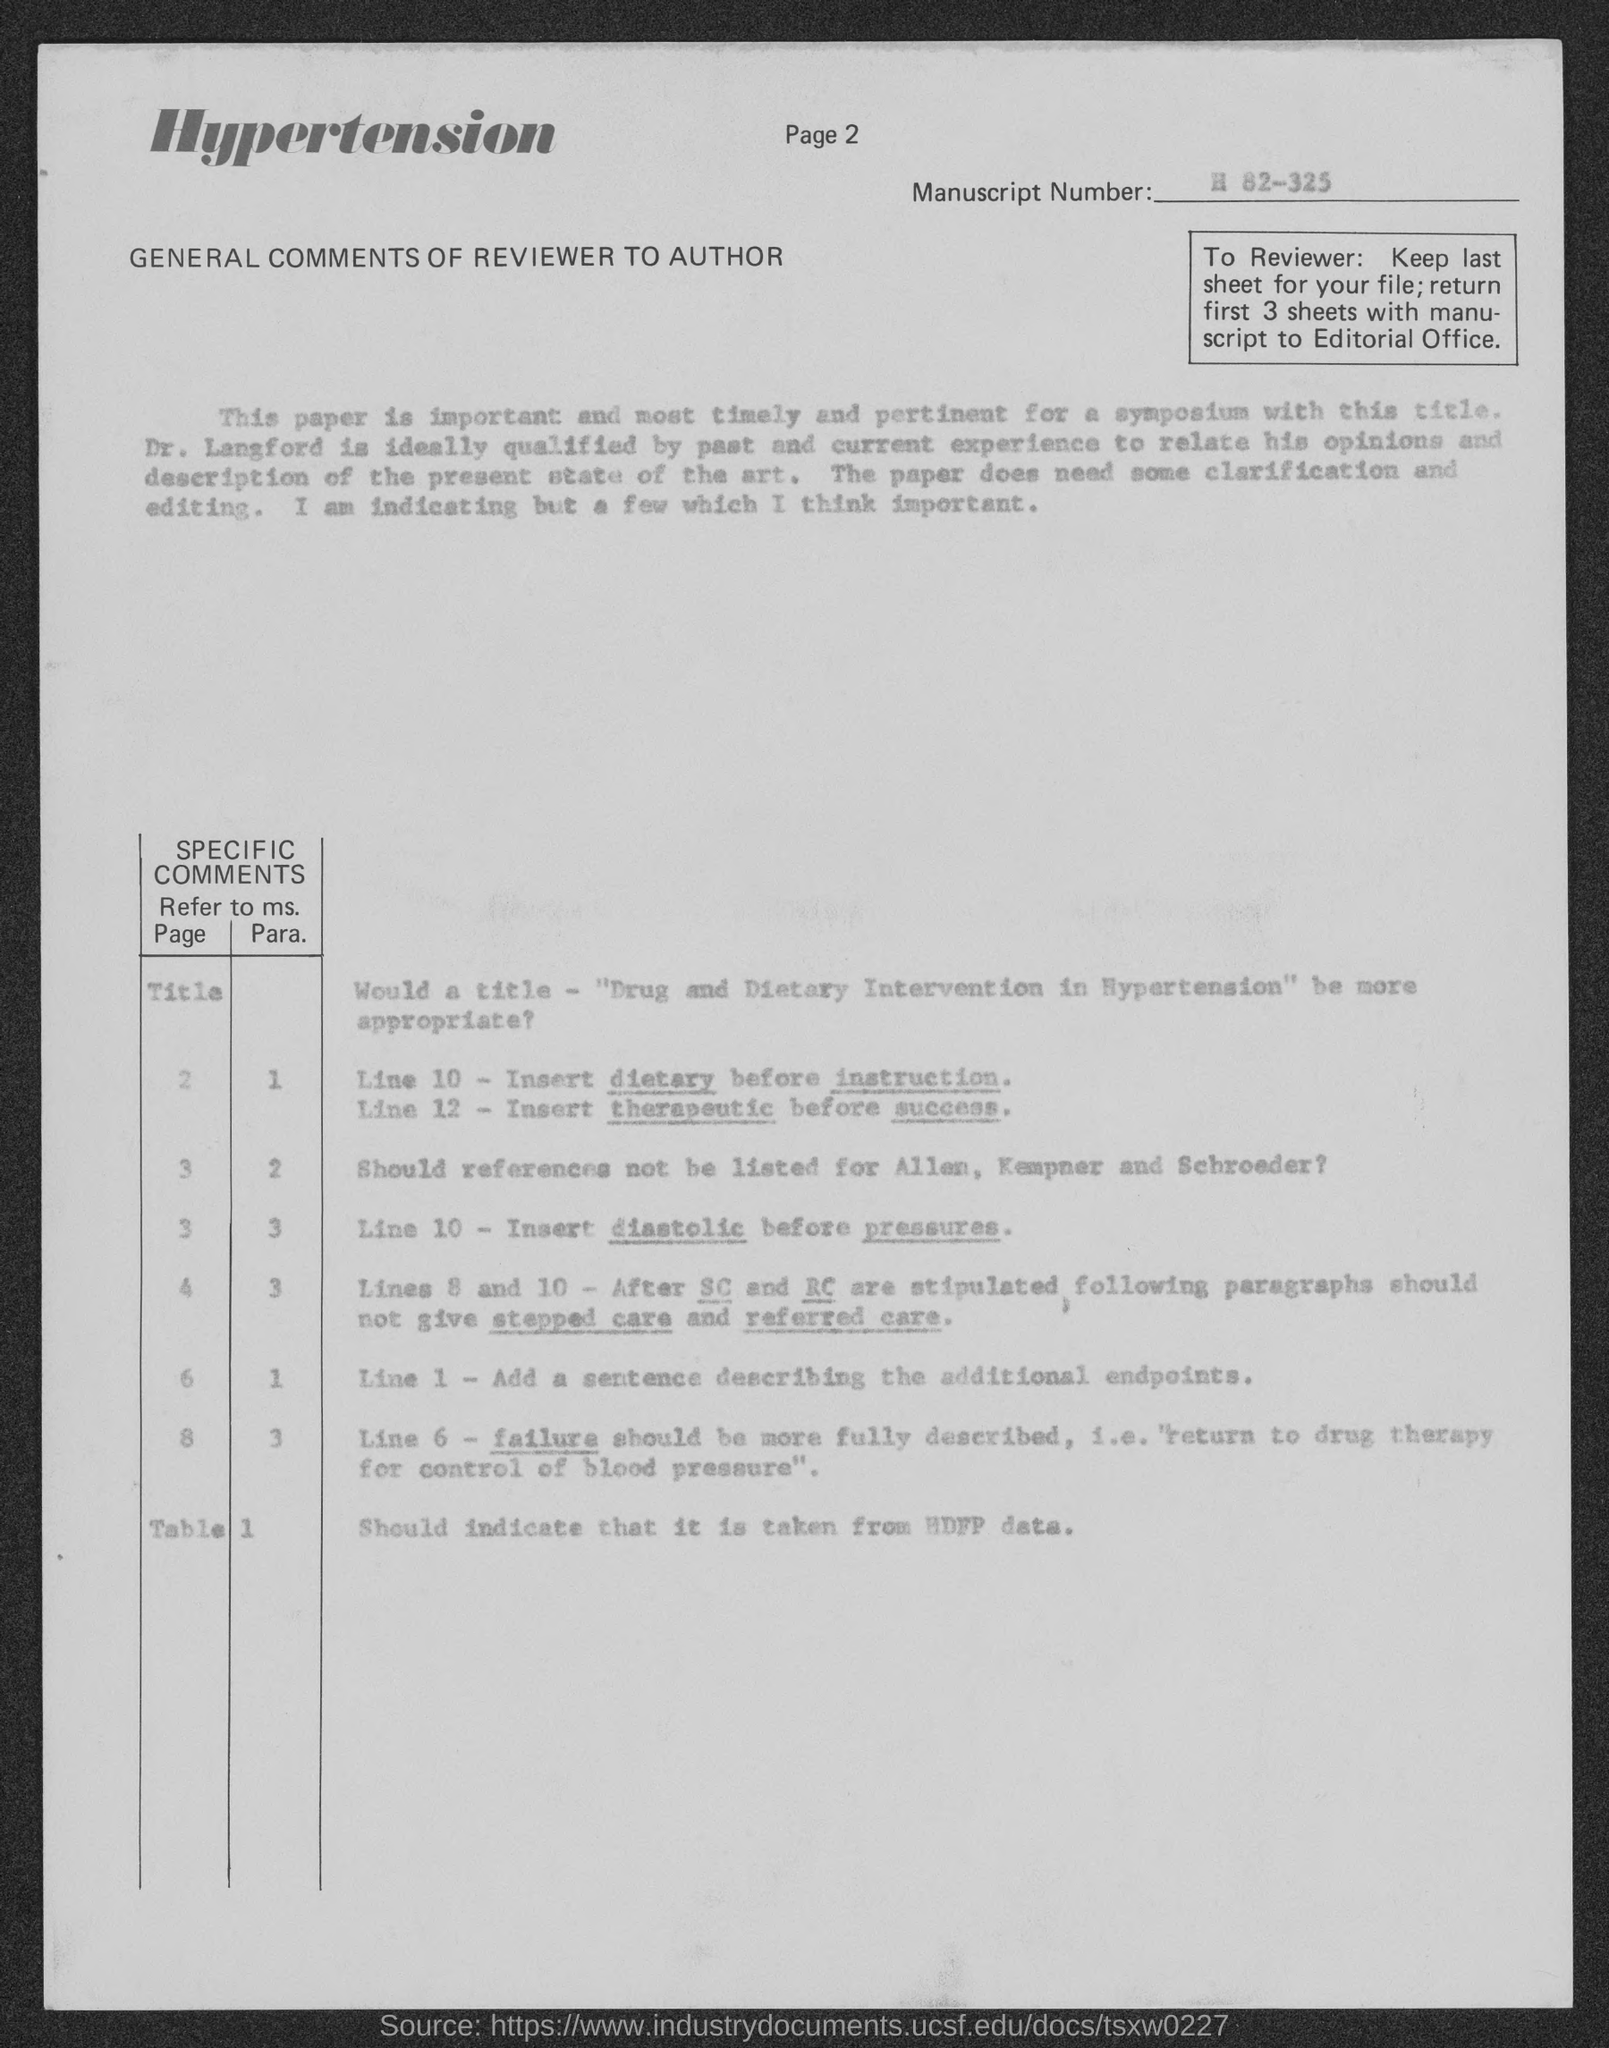Point out several critical features in this image. The page number at the top of the page is 2. The manuscript number is H 82-325. 